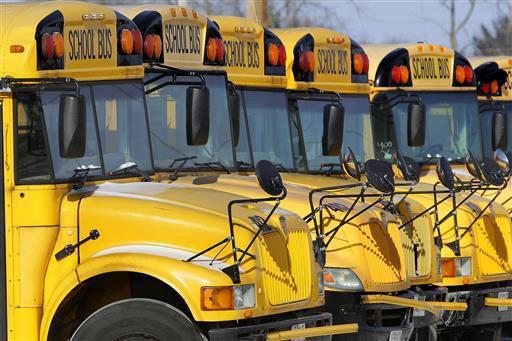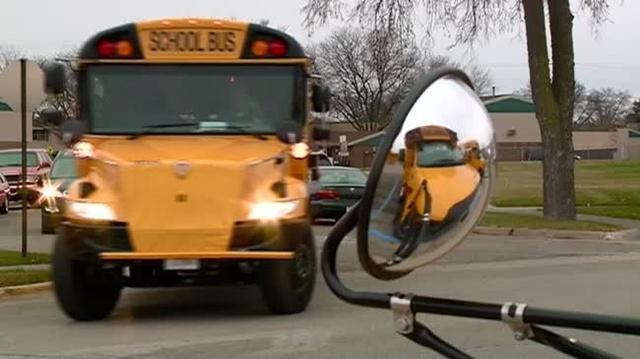The first image is the image on the left, the second image is the image on the right. Examine the images to the left and right. Is the description "At least 2 people are standing on the ground next to the school bus." accurate? Answer yes or no. No. The first image is the image on the left, the second image is the image on the right. Analyze the images presented: Is the assertion "People stand outside the bus in the image on the right." valid? Answer yes or no. No. 